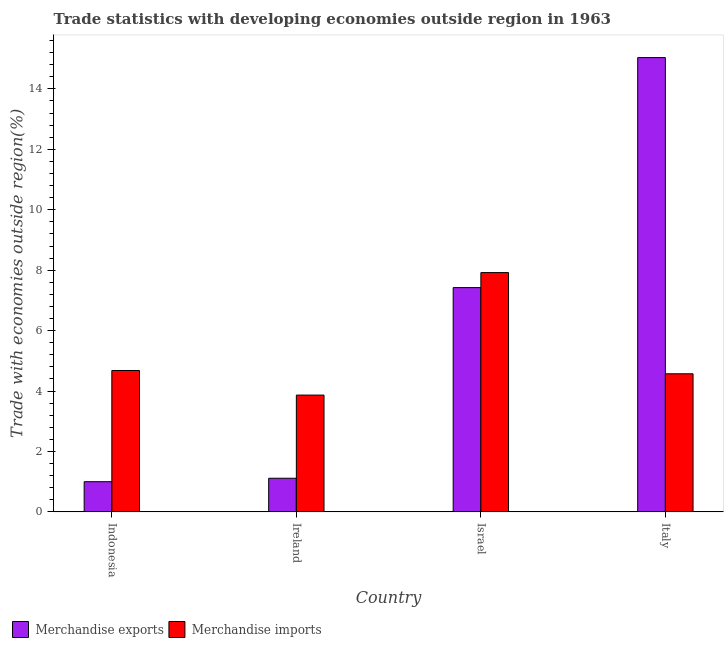Are the number of bars per tick equal to the number of legend labels?
Offer a very short reply. Yes. How many bars are there on the 4th tick from the right?
Give a very brief answer. 2. What is the label of the 3rd group of bars from the left?
Keep it short and to the point. Israel. What is the merchandise imports in Ireland?
Provide a short and direct response. 3.87. Across all countries, what is the maximum merchandise imports?
Your answer should be very brief. 7.92. Across all countries, what is the minimum merchandise imports?
Offer a terse response. 3.87. In which country was the merchandise imports maximum?
Your answer should be very brief. Israel. In which country was the merchandise imports minimum?
Your answer should be compact. Ireland. What is the total merchandise imports in the graph?
Offer a very short reply. 21.03. What is the difference between the merchandise imports in Israel and that in Italy?
Ensure brevity in your answer.  3.35. What is the difference between the merchandise exports in Israel and the merchandise imports in Indonesia?
Offer a very short reply. 2.74. What is the average merchandise imports per country?
Provide a succinct answer. 5.26. What is the difference between the merchandise imports and merchandise exports in Italy?
Give a very brief answer. -10.47. What is the ratio of the merchandise imports in Israel to that in Italy?
Provide a short and direct response. 1.73. Is the merchandise exports in Israel less than that in Italy?
Offer a terse response. Yes. Is the difference between the merchandise exports in Indonesia and Israel greater than the difference between the merchandise imports in Indonesia and Israel?
Your answer should be compact. No. What is the difference between the highest and the second highest merchandise exports?
Your response must be concise. 7.61. What is the difference between the highest and the lowest merchandise exports?
Offer a terse response. 14.04. In how many countries, is the merchandise exports greater than the average merchandise exports taken over all countries?
Make the answer very short. 2. Is the sum of the merchandise imports in Ireland and Israel greater than the maximum merchandise exports across all countries?
Keep it short and to the point. No. What does the 2nd bar from the left in Israel represents?
Keep it short and to the point. Merchandise imports. Are all the bars in the graph horizontal?
Ensure brevity in your answer.  No. How many countries are there in the graph?
Your answer should be very brief. 4. What is the difference between two consecutive major ticks on the Y-axis?
Provide a succinct answer. 2. Are the values on the major ticks of Y-axis written in scientific E-notation?
Provide a short and direct response. No. Does the graph contain grids?
Provide a short and direct response. No. Where does the legend appear in the graph?
Provide a short and direct response. Bottom left. How many legend labels are there?
Offer a very short reply. 2. What is the title of the graph?
Offer a very short reply. Trade statistics with developing economies outside region in 1963. Does "From human activities" appear as one of the legend labels in the graph?
Your answer should be compact. No. What is the label or title of the X-axis?
Provide a short and direct response. Country. What is the label or title of the Y-axis?
Keep it short and to the point. Trade with economies outside region(%). What is the Trade with economies outside region(%) of Merchandise exports in Indonesia?
Give a very brief answer. 1. What is the Trade with economies outside region(%) in Merchandise imports in Indonesia?
Make the answer very short. 4.68. What is the Trade with economies outside region(%) in Merchandise exports in Ireland?
Offer a very short reply. 1.11. What is the Trade with economies outside region(%) of Merchandise imports in Ireland?
Your response must be concise. 3.87. What is the Trade with economies outside region(%) in Merchandise exports in Israel?
Provide a short and direct response. 7.42. What is the Trade with economies outside region(%) in Merchandise imports in Israel?
Give a very brief answer. 7.92. What is the Trade with economies outside region(%) of Merchandise exports in Italy?
Keep it short and to the point. 15.04. What is the Trade with economies outside region(%) of Merchandise imports in Italy?
Provide a short and direct response. 4.57. Across all countries, what is the maximum Trade with economies outside region(%) of Merchandise exports?
Your answer should be very brief. 15.04. Across all countries, what is the maximum Trade with economies outside region(%) of Merchandise imports?
Your answer should be very brief. 7.92. Across all countries, what is the minimum Trade with economies outside region(%) in Merchandise exports?
Provide a short and direct response. 1. Across all countries, what is the minimum Trade with economies outside region(%) in Merchandise imports?
Make the answer very short. 3.87. What is the total Trade with economies outside region(%) of Merchandise exports in the graph?
Make the answer very short. 24.57. What is the total Trade with economies outside region(%) in Merchandise imports in the graph?
Give a very brief answer. 21.04. What is the difference between the Trade with economies outside region(%) of Merchandise exports in Indonesia and that in Ireland?
Your answer should be compact. -0.11. What is the difference between the Trade with economies outside region(%) in Merchandise imports in Indonesia and that in Ireland?
Offer a very short reply. 0.81. What is the difference between the Trade with economies outside region(%) in Merchandise exports in Indonesia and that in Israel?
Keep it short and to the point. -6.42. What is the difference between the Trade with economies outside region(%) in Merchandise imports in Indonesia and that in Israel?
Make the answer very short. -3.24. What is the difference between the Trade with economies outside region(%) of Merchandise exports in Indonesia and that in Italy?
Your response must be concise. -14.04. What is the difference between the Trade with economies outside region(%) of Merchandise imports in Indonesia and that in Italy?
Provide a short and direct response. 0.11. What is the difference between the Trade with economies outside region(%) in Merchandise exports in Ireland and that in Israel?
Give a very brief answer. -6.31. What is the difference between the Trade with economies outside region(%) of Merchandise imports in Ireland and that in Israel?
Provide a short and direct response. -4.05. What is the difference between the Trade with economies outside region(%) in Merchandise exports in Ireland and that in Italy?
Keep it short and to the point. -13.92. What is the difference between the Trade with economies outside region(%) of Merchandise imports in Ireland and that in Italy?
Ensure brevity in your answer.  -0.7. What is the difference between the Trade with economies outside region(%) of Merchandise exports in Israel and that in Italy?
Offer a very short reply. -7.61. What is the difference between the Trade with economies outside region(%) in Merchandise imports in Israel and that in Italy?
Make the answer very short. 3.35. What is the difference between the Trade with economies outside region(%) in Merchandise exports in Indonesia and the Trade with economies outside region(%) in Merchandise imports in Ireland?
Provide a succinct answer. -2.87. What is the difference between the Trade with economies outside region(%) of Merchandise exports in Indonesia and the Trade with economies outside region(%) of Merchandise imports in Israel?
Offer a terse response. -6.92. What is the difference between the Trade with economies outside region(%) in Merchandise exports in Indonesia and the Trade with economies outside region(%) in Merchandise imports in Italy?
Provide a short and direct response. -3.57. What is the difference between the Trade with economies outside region(%) of Merchandise exports in Ireland and the Trade with economies outside region(%) of Merchandise imports in Israel?
Give a very brief answer. -6.81. What is the difference between the Trade with economies outside region(%) of Merchandise exports in Ireland and the Trade with economies outside region(%) of Merchandise imports in Italy?
Offer a terse response. -3.46. What is the difference between the Trade with economies outside region(%) of Merchandise exports in Israel and the Trade with economies outside region(%) of Merchandise imports in Italy?
Give a very brief answer. 2.85. What is the average Trade with economies outside region(%) of Merchandise exports per country?
Provide a short and direct response. 6.14. What is the average Trade with economies outside region(%) of Merchandise imports per country?
Keep it short and to the point. 5.26. What is the difference between the Trade with economies outside region(%) in Merchandise exports and Trade with economies outside region(%) in Merchandise imports in Indonesia?
Provide a short and direct response. -3.68. What is the difference between the Trade with economies outside region(%) in Merchandise exports and Trade with economies outside region(%) in Merchandise imports in Ireland?
Your response must be concise. -2.75. What is the difference between the Trade with economies outside region(%) of Merchandise exports and Trade with economies outside region(%) of Merchandise imports in Israel?
Ensure brevity in your answer.  -0.5. What is the difference between the Trade with economies outside region(%) in Merchandise exports and Trade with economies outside region(%) in Merchandise imports in Italy?
Offer a very short reply. 10.47. What is the ratio of the Trade with economies outside region(%) of Merchandise exports in Indonesia to that in Ireland?
Provide a short and direct response. 0.9. What is the ratio of the Trade with economies outside region(%) of Merchandise imports in Indonesia to that in Ireland?
Give a very brief answer. 1.21. What is the ratio of the Trade with economies outside region(%) in Merchandise exports in Indonesia to that in Israel?
Your answer should be compact. 0.13. What is the ratio of the Trade with economies outside region(%) of Merchandise imports in Indonesia to that in Israel?
Give a very brief answer. 0.59. What is the ratio of the Trade with economies outside region(%) of Merchandise exports in Indonesia to that in Italy?
Make the answer very short. 0.07. What is the ratio of the Trade with economies outside region(%) in Merchandise imports in Indonesia to that in Italy?
Your answer should be compact. 1.02. What is the ratio of the Trade with economies outside region(%) of Merchandise exports in Ireland to that in Israel?
Provide a short and direct response. 0.15. What is the ratio of the Trade with economies outside region(%) in Merchandise imports in Ireland to that in Israel?
Make the answer very short. 0.49. What is the ratio of the Trade with economies outside region(%) in Merchandise exports in Ireland to that in Italy?
Your answer should be very brief. 0.07. What is the ratio of the Trade with economies outside region(%) in Merchandise imports in Ireland to that in Italy?
Provide a short and direct response. 0.85. What is the ratio of the Trade with economies outside region(%) in Merchandise exports in Israel to that in Italy?
Make the answer very short. 0.49. What is the ratio of the Trade with economies outside region(%) in Merchandise imports in Israel to that in Italy?
Ensure brevity in your answer.  1.73. What is the difference between the highest and the second highest Trade with economies outside region(%) in Merchandise exports?
Provide a succinct answer. 7.61. What is the difference between the highest and the second highest Trade with economies outside region(%) in Merchandise imports?
Offer a terse response. 3.24. What is the difference between the highest and the lowest Trade with economies outside region(%) in Merchandise exports?
Provide a short and direct response. 14.04. What is the difference between the highest and the lowest Trade with economies outside region(%) in Merchandise imports?
Provide a short and direct response. 4.05. 